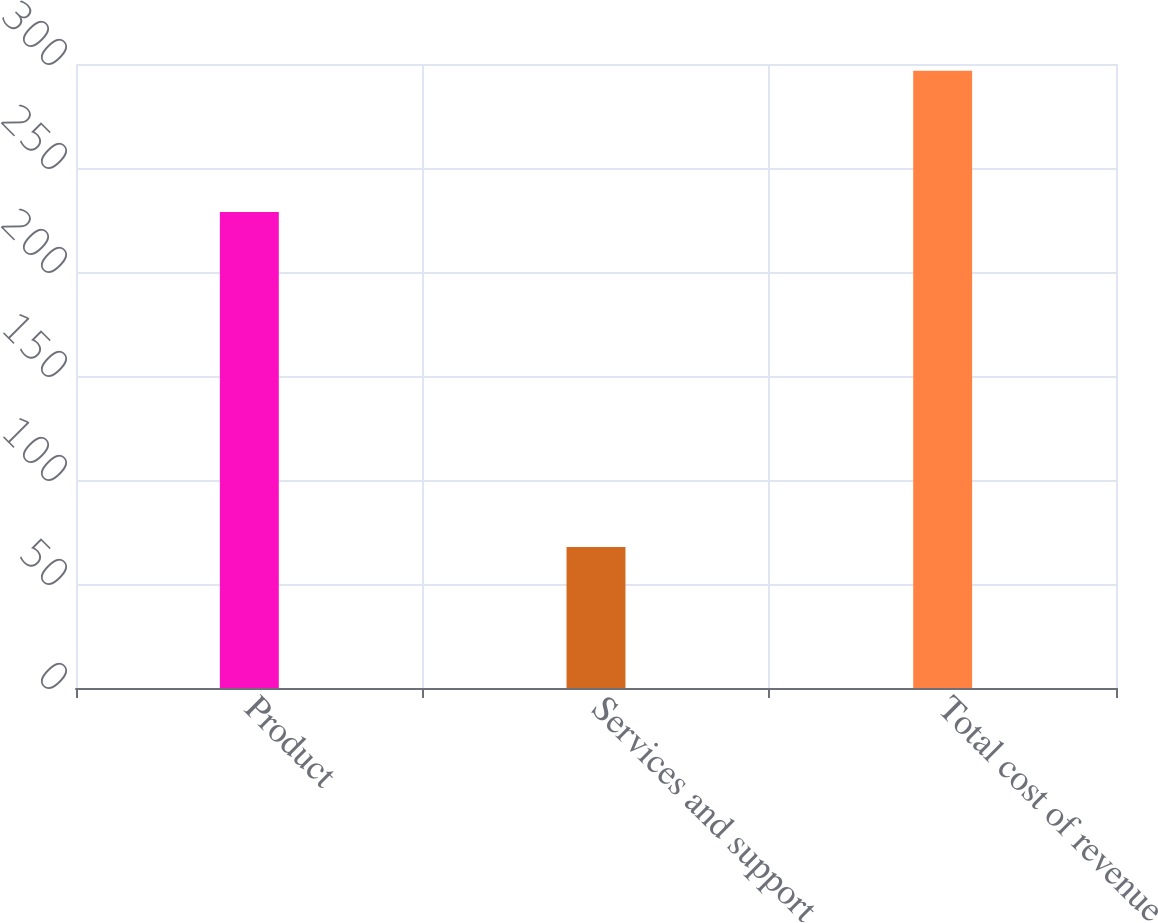Convert chart to OTSL. <chart><loc_0><loc_0><loc_500><loc_500><bar_chart><fcel>Product<fcel>Services and support<fcel>Total cost of revenue<nl><fcel>228.9<fcel>67.8<fcel>296.7<nl></chart> 